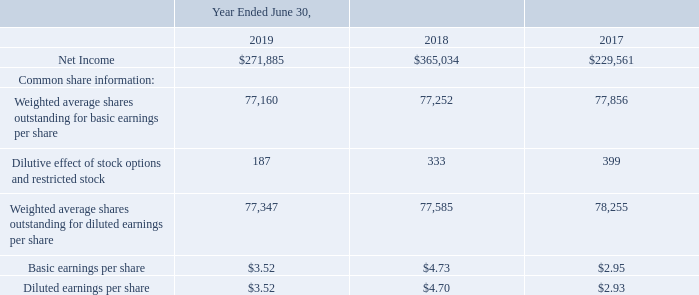NOTE 10. EARNINGS PER SHARE
The following table reflects the reconciliation between basic and diluted earnings per share.
Per share information is based on the weighted average number of common shares outstanding for each of the fiscal years. Stock options and restricted stock have been included in the calculation of earnings per share to the extent they are dilutive. The two-class method for computing EPS has not been applied because no outstanding awards contain non-forfeitable rights to participate in dividends. There were no anti-dilutive stock options and restricted stock excluded for fiscal 2019, 41 shares excluded for fiscal 2018, and 32 shares excluded for fiscal 2017.
What does the table show? The reconciliation between basic and diluted earnings per share. Which financial years' information is shown in the table? 2017, 2018, 2019. What is the net income as at June 30, 2019? $271,885. What is the average net income for 2018 and 2019? (271,885+365,034)/2
Answer: 318459.5. What is the average basic earnings per share for 2018 and 2019? (3.52+4.73)/2
Answer: 4.12. What is the average basic earnings per share for 2017 and 2018? (4.73+2.95)/2
Answer: 3.84. 